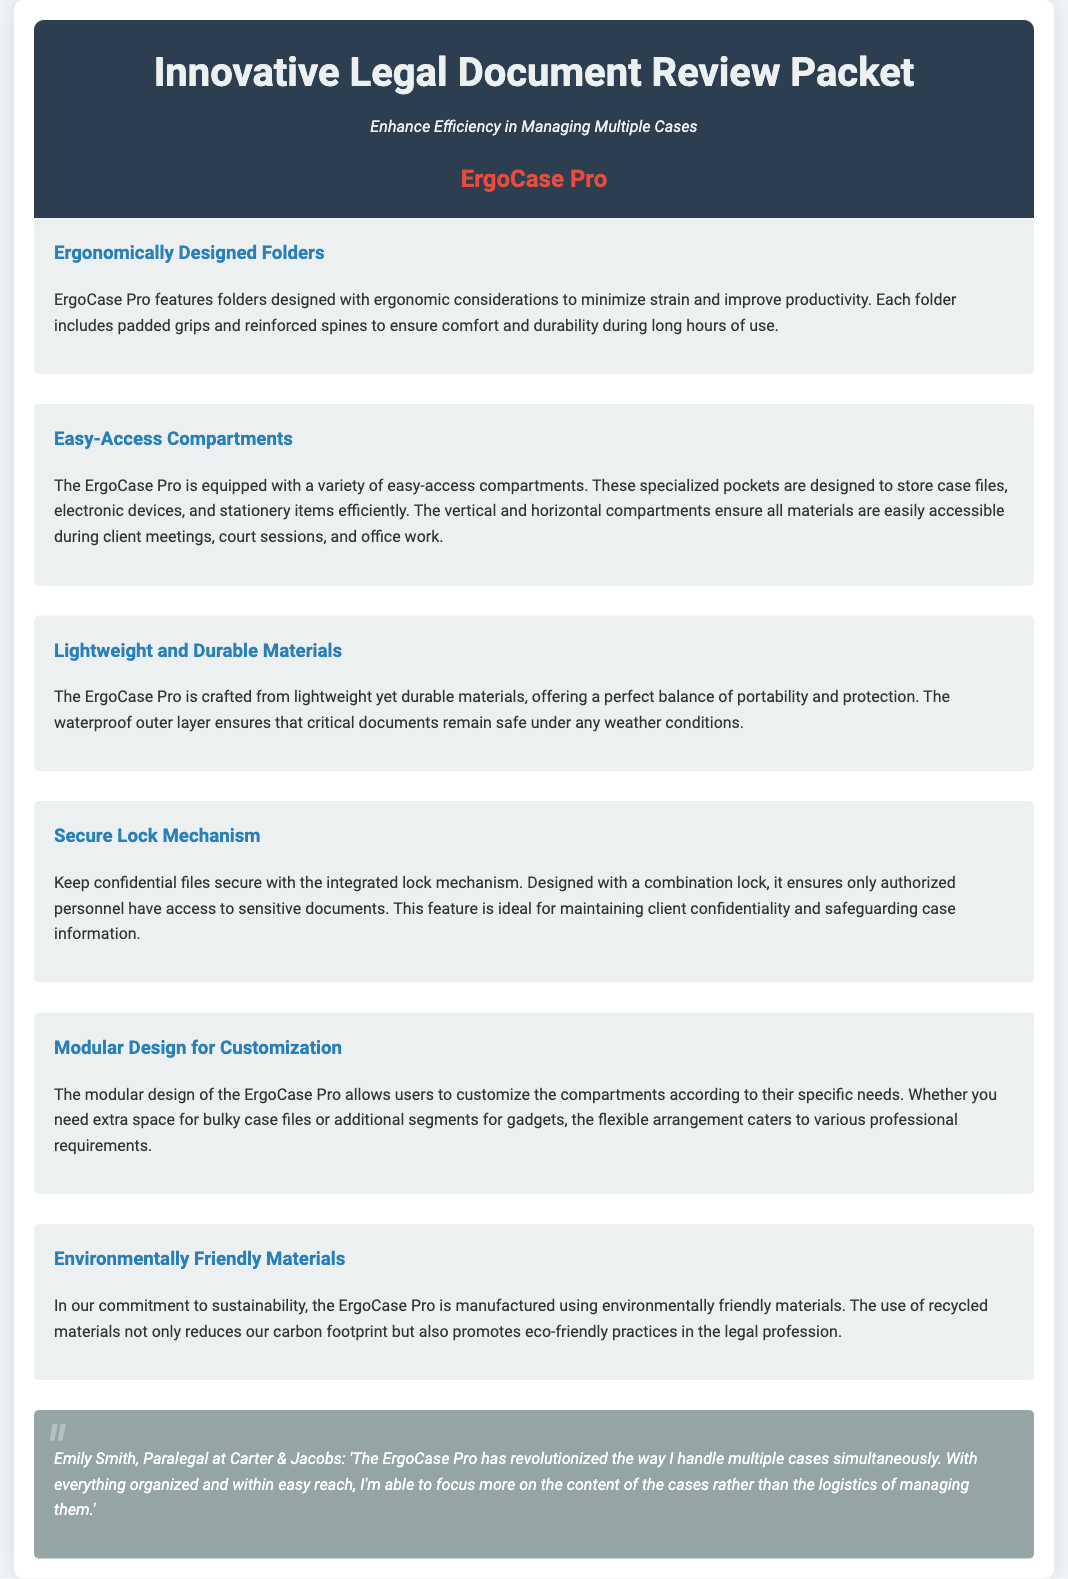What is the product name? The product name is mentioned in the document header, identifying the innovative legal document review solution.
Answer: ErgoCase Pro What feature minimizes strain during use? The document describes specific design features intended to enhance comfort and productivity during prolonged use.
Answer: Ergonomically Designed Folders What type of lock is integrated into the product? The document states the type of security mechanism used to protect sensitive information in the case.
Answer: Combination lock What is the design feature that allows for personalization? The modular nature of the product allows adjustments according to user needs, as stated in the document.
Answer: Modular Design for Customization What material is mentioned for weather protection? The document highlights a specific aspect related to the protection of documents against weather conditions.
Answer: Waterproof outer layer How does the product promote sustainability? The document specifies the materials used in manufacturing that contribute to environmental benefits.
Answer: Environmentally Friendly Materials Who provided a testimonial for the product? The document includes a personal endorsement from a professional, identifying their role and organization.
Answer: Emily Smith, Paralegal at Carter & Jacobs What aspect enhances accessibility in the product? The document references a design feature that facilitates easy retrieval of materials during use.
Answer: Easy-Access Compartments What color is associated with the product name? The document mentions a specific color that distinguishes the product name from others in the design.
Answer: Red 